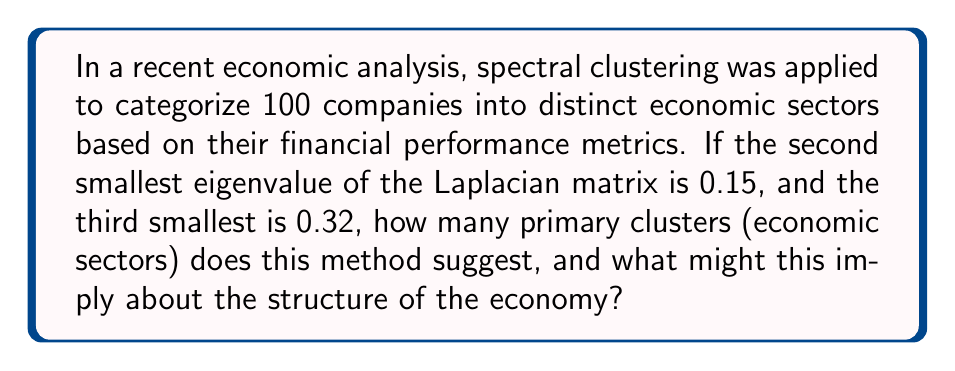Provide a solution to this math problem. To determine the number of clusters using spectral clustering, we follow these steps:

1) In spectral clustering, the number of clusters is typically determined by the eigengap heuristic.

2) The eigengap is the largest difference between two consecutive eigenvalues of the Laplacian matrix.

3) We're given:
   - Second smallest eigenvalue: $\lambda_2 = 0.15$
   - Third smallest eigenvalue: $\lambda_3 = 0.32$

4) Calculate the eigengap:
   $\text{eigengap} = \lambda_3 - \lambda_2 = 0.32 - 0.15 = 0.17$

5) This significant gap between $\lambda_2$ and $\lambda_3$ suggests that the optimal number of clusters is 2.

6) Interpretation: This implies that the economy, based on the analyzed metrics, can be primarily divided into two major sectors. This binary division could suggest:
   - A traditional sector vs. a modern/innovative sector
   - A goods-producing sector vs. a service-providing sector
   - A domestic-focused sector vs. an export-oriented sector

7) However, this simplified two-sector model may oversimplify the complex nature of the economy, potentially overlooking important nuances and sub-sectors.
Answer: 2 clusters 